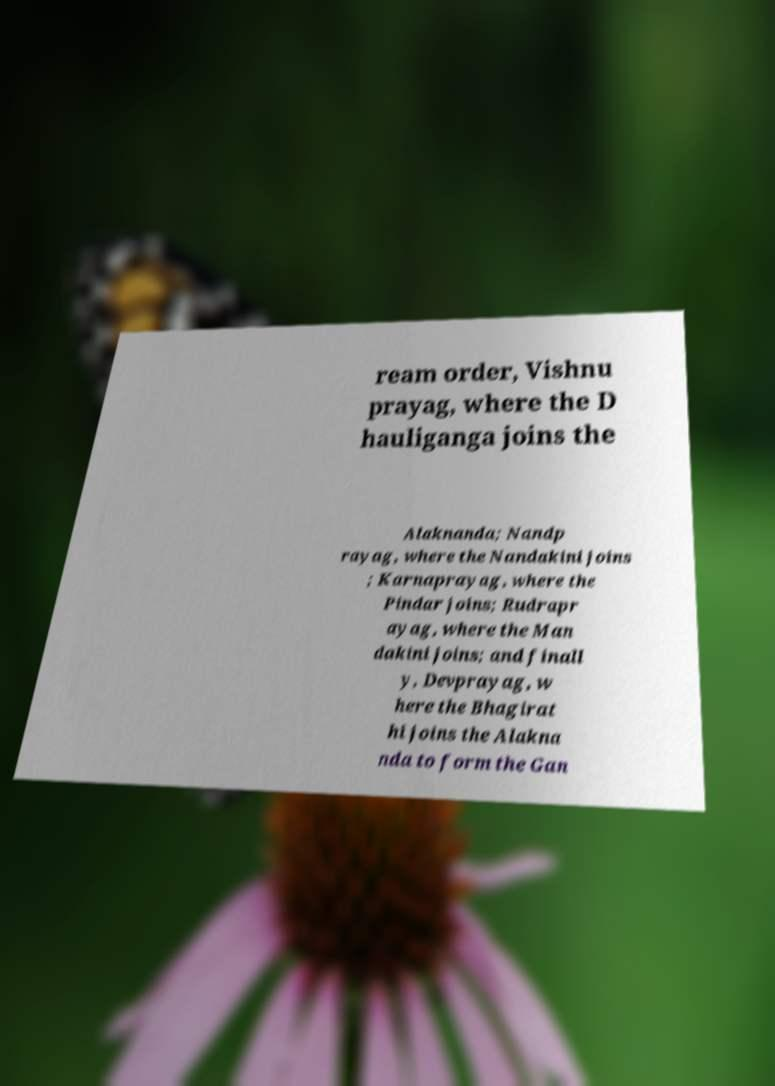There's text embedded in this image that I need extracted. Can you transcribe it verbatim? ream order, Vishnu prayag, where the D hauliganga joins the Alaknanda; Nandp rayag, where the Nandakini joins ; Karnaprayag, where the Pindar joins; Rudrapr ayag, where the Man dakini joins; and finall y, Devprayag, w here the Bhagirat hi joins the Alakna nda to form the Gan 